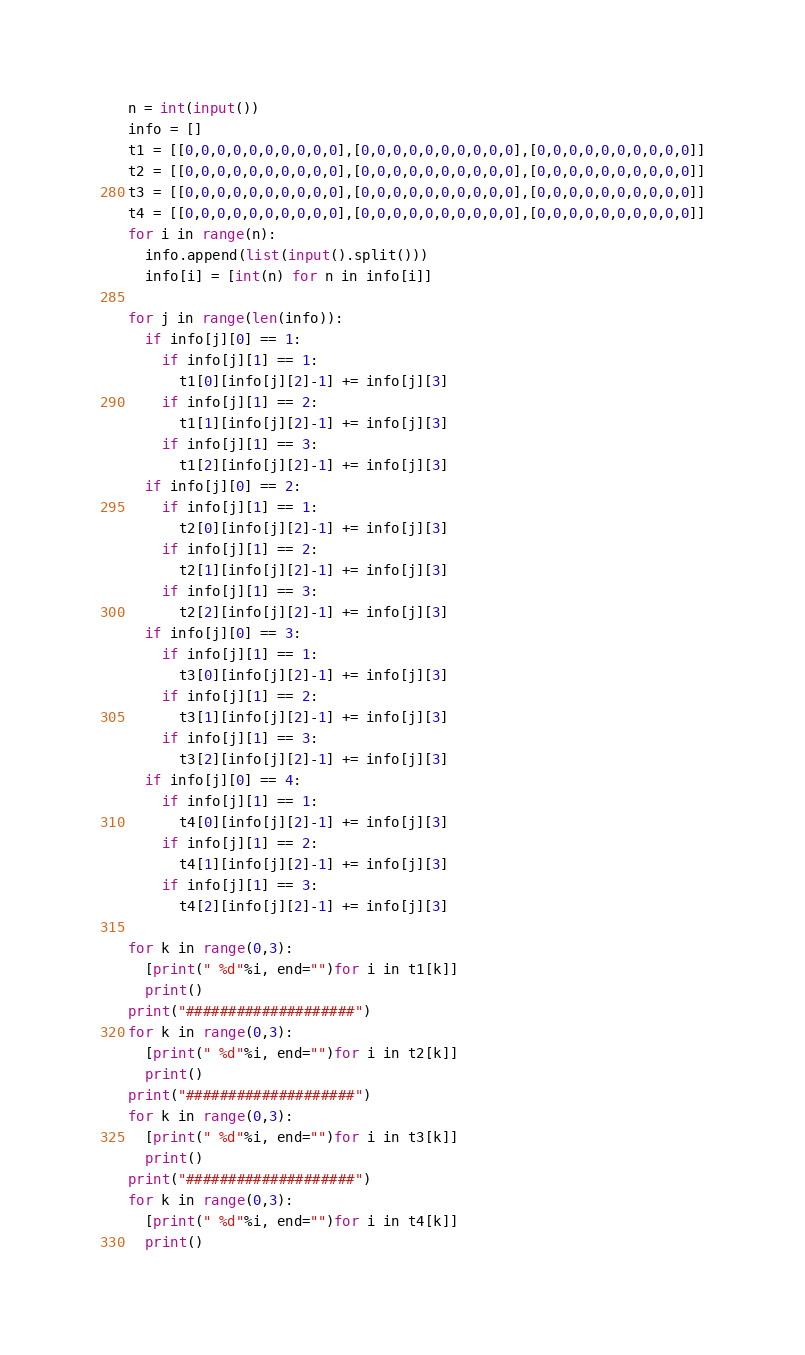<code> <loc_0><loc_0><loc_500><loc_500><_Python_>n = int(input())
info = []
t1 = [[0,0,0,0,0,0,0,0,0,0],[0,0,0,0,0,0,0,0,0,0],[0,0,0,0,0,0,0,0,0,0]]
t2 = [[0,0,0,0,0,0,0,0,0,0],[0,0,0,0,0,0,0,0,0,0],[0,0,0,0,0,0,0,0,0,0]]
t3 = [[0,0,0,0,0,0,0,0,0,0],[0,0,0,0,0,0,0,0,0,0],[0,0,0,0,0,0,0,0,0,0]]
t4 = [[0,0,0,0,0,0,0,0,0,0],[0,0,0,0,0,0,0,0,0,0],[0,0,0,0,0,0,0,0,0,0]]
for i in range(n):
  info.append(list(input().split()))
  info[i] = [int(n) for n in info[i]]

for j in range(len(info)):
  if info[j][0] == 1:
    if info[j][1] == 1:
      t1[0][info[j][2]-1] += info[j][3]
    if info[j][1] == 2:
      t1[1][info[j][2]-1] += info[j][3]
    if info[j][1] == 3:
      t1[2][info[j][2]-1] += info[j][3]
  if info[j][0] == 2:
    if info[j][1] == 1:
      t2[0][info[j][2]-1] += info[j][3]
    if info[j][1] == 2:
      t2[1][info[j][2]-1] += info[j][3]
    if info[j][1] == 3:
      t2[2][info[j][2]-1] += info[j][3]
  if info[j][0] == 3:
    if info[j][1] == 1:
      t3[0][info[j][2]-1] += info[j][3]
    if info[j][1] == 2:
      t3[1][info[j][2]-1] += info[j][3]
    if info[j][1] == 3:
      t3[2][info[j][2]-1] += info[j][3]
  if info[j][0] == 4:
    if info[j][1] == 1:
      t4[0][info[j][2]-1] += info[j][3]
    if info[j][1] == 2:
      t4[1][info[j][2]-1] += info[j][3]
    if info[j][1] == 3:
      t4[2][info[j][2]-1] += info[j][3]
  
for k in range(0,3):
  [print(" %d"%i, end="")for i in t1[k]]
  print()
print("####################")
for k in range(0,3):
  [print(" %d"%i, end="")for i in t2[k]]
  print()
print("####################")
for k in range(0,3):
  [print(" %d"%i, end="")for i in t3[k]]
  print()
print("####################")
for k in range(0,3):
  [print(" %d"%i, end="")for i in t4[k]]
  print()
</code> 